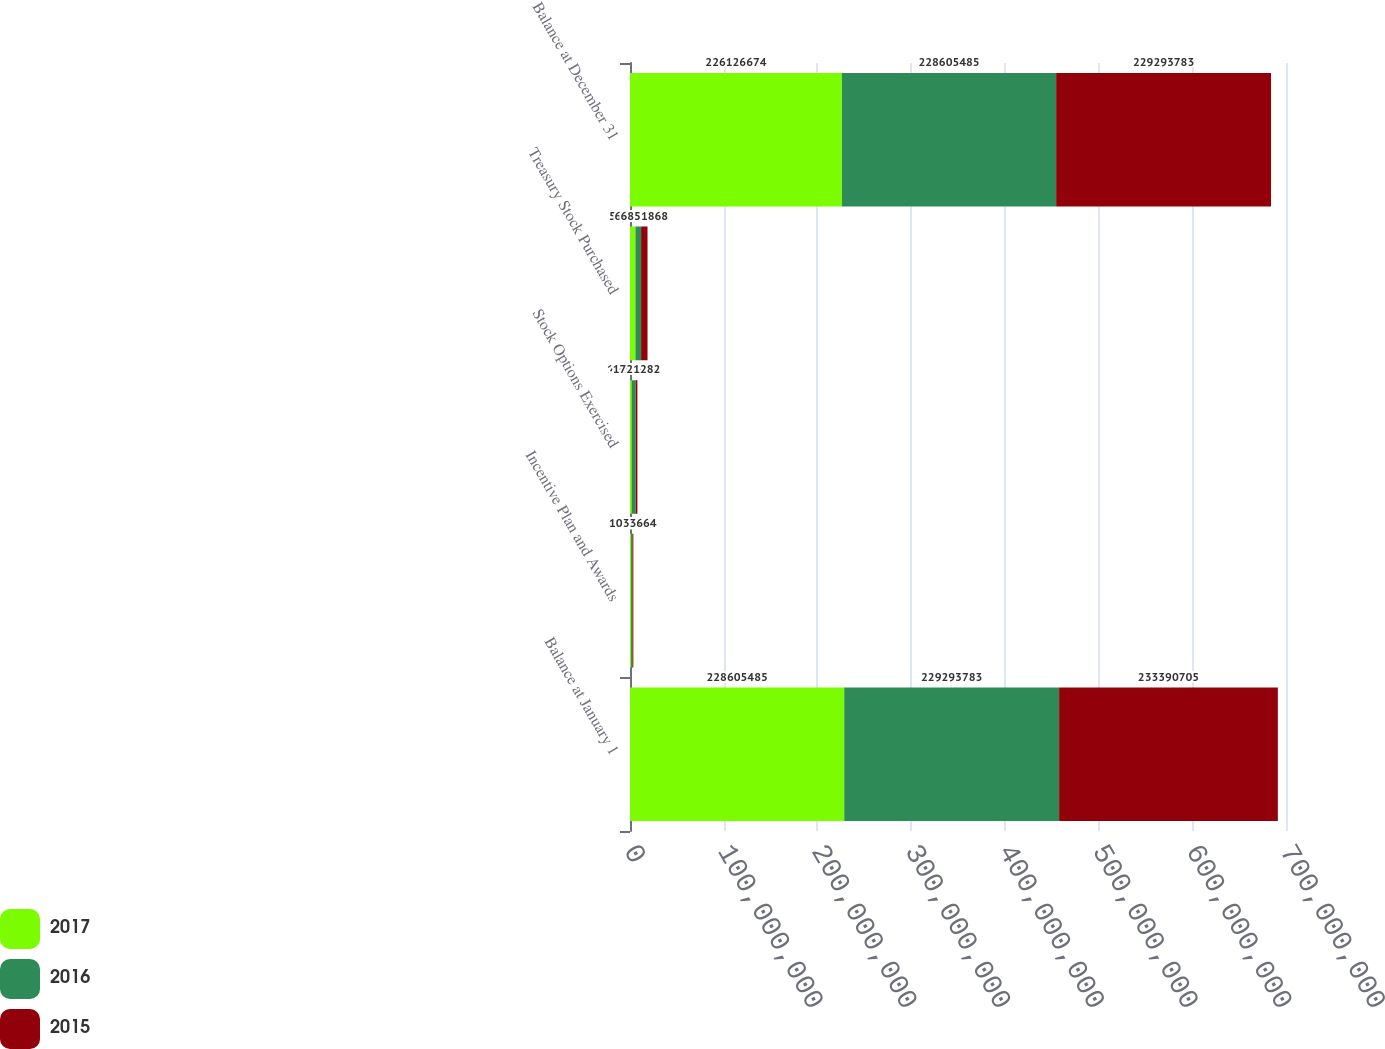Convert chart to OTSL. <chart><loc_0><loc_0><loc_500><loc_500><stacked_bar_chart><ecel><fcel>Balance at January 1<fcel>Incentive Plan and Awards<fcel>Stock Options Exercised<fcel>Treasury Stock Purchased<fcel>Balance at December 31<nl><fcel>2017<fcel>2.28605e+08<fcel>1.32013e+06<fcel>1.99736e+06<fcel>5.7963e+06<fcel>2.26127e+08<nl><fcel>2016<fcel>2.29294e+08<fcel>1.20912e+06<fcel>4.15673e+06<fcel>6.05415e+06<fcel>2.28605e+08<nl><fcel>2015<fcel>2.33391e+08<fcel>1.03366e+06<fcel>1.72128e+06<fcel>6.85187e+06<fcel>2.29294e+08<nl></chart> 